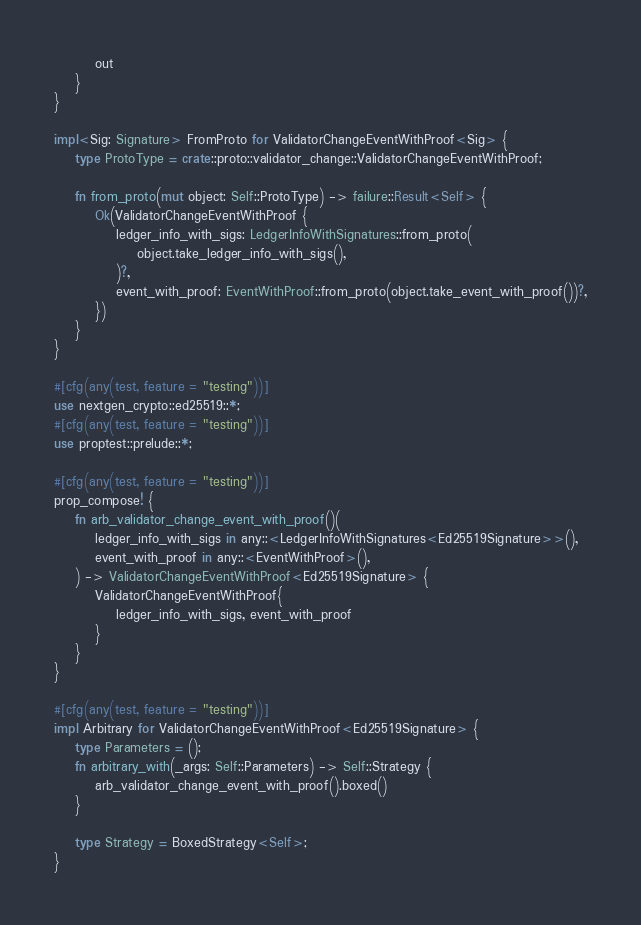<code> <loc_0><loc_0><loc_500><loc_500><_Rust_>        out
    }
}

impl<Sig: Signature> FromProto for ValidatorChangeEventWithProof<Sig> {
    type ProtoType = crate::proto::validator_change::ValidatorChangeEventWithProof;

    fn from_proto(mut object: Self::ProtoType) -> failure::Result<Self> {
        Ok(ValidatorChangeEventWithProof {
            ledger_info_with_sigs: LedgerInfoWithSignatures::from_proto(
                object.take_ledger_info_with_sigs(),
            )?,
            event_with_proof: EventWithProof::from_proto(object.take_event_with_proof())?,
        })
    }
}

#[cfg(any(test, feature = "testing"))]
use nextgen_crypto::ed25519::*;
#[cfg(any(test, feature = "testing"))]
use proptest::prelude::*;

#[cfg(any(test, feature = "testing"))]
prop_compose! {
    fn arb_validator_change_event_with_proof()(
        ledger_info_with_sigs in any::<LedgerInfoWithSignatures<Ed25519Signature>>(),
        event_with_proof in any::<EventWithProof>(),
    ) -> ValidatorChangeEventWithProof<Ed25519Signature> {
        ValidatorChangeEventWithProof{
            ledger_info_with_sigs, event_with_proof
        }
    }
}

#[cfg(any(test, feature = "testing"))]
impl Arbitrary for ValidatorChangeEventWithProof<Ed25519Signature> {
    type Parameters = ();
    fn arbitrary_with(_args: Self::Parameters) -> Self::Strategy {
        arb_validator_change_event_with_proof().boxed()
    }

    type Strategy = BoxedStrategy<Self>;
}
</code> 